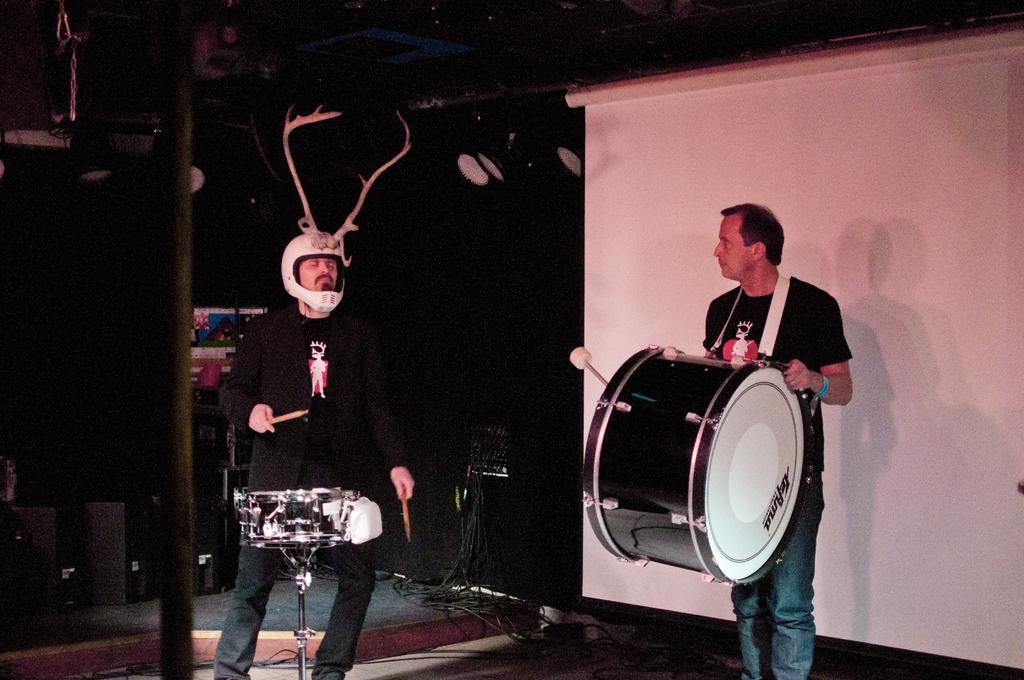How many people are in the image? There are two men in the image. What are the men doing in the image? The men are playing drums. What type of crack is visible on the drum in the image? There is no crack visible on the drum in the image. 